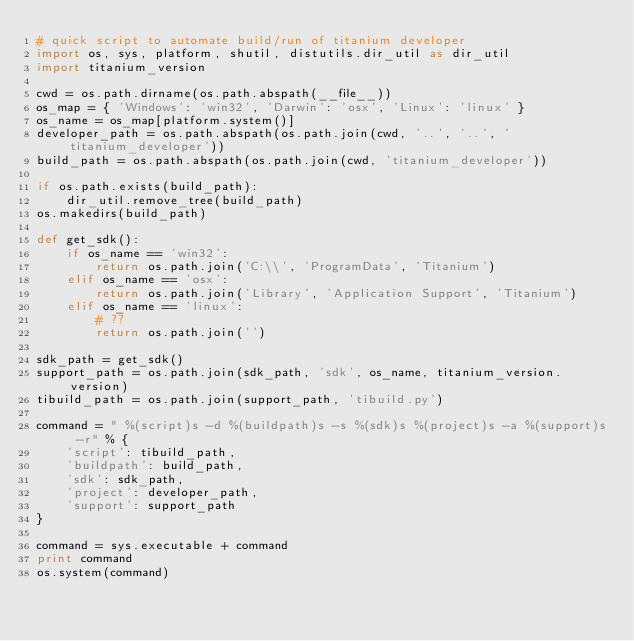Convert code to text. <code><loc_0><loc_0><loc_500><loc_500><_Python_># quick script to automate build/run of titanium developer
import os, sys, platform, shutil, distutils.dir_util as dir_util
import titanium_version

cwd = os.path.dirname(os.path.abspath(__file__))
os_map = { 'Windows': 'win32', 'Darwin': 'osx', 'Linux': 'linux' }
os_name = os_map[platform.system()]
developer_path = os.path.abspath(os.path.join(cwd, '..', '..', 'titanium_developer'))
build_path = os.path.abspath(os.path.join(cwd, 'titanium_developer'))

if os.path.exists(build_path):
	dir_util.remove_tree(build_path)
os.makedirs(build_path)

def get_sdk():
	if os_name == 'win32':
		return os.path.join('C:\\', 'ProgramData', 'Titanium')
	elif os_name == 'osx':
		return os.path.join('Library', 'Application Support', 'Titanium')
	elif os_name == 'linux':
		# ??
		return os.path.join('')

sdk_path = get_sdk()
support_path = os.path.join(sdk_path, 'sdk', os_name, titanium_version.version)
tibuild_path = os.path.join(support_path, 'tibuild.py')

command = " %(script)s -d %(buildpath)s -s %(sdk)s %(project)s -a %(support)s -r" % {
	'script': tibuild_path,
	'buildpath': build_path,
	'sdk': sdk_path,
	'project': developer_path,
	'support': support_path
}

command = sys.executable + command
print command
os.system(command)
</code> 